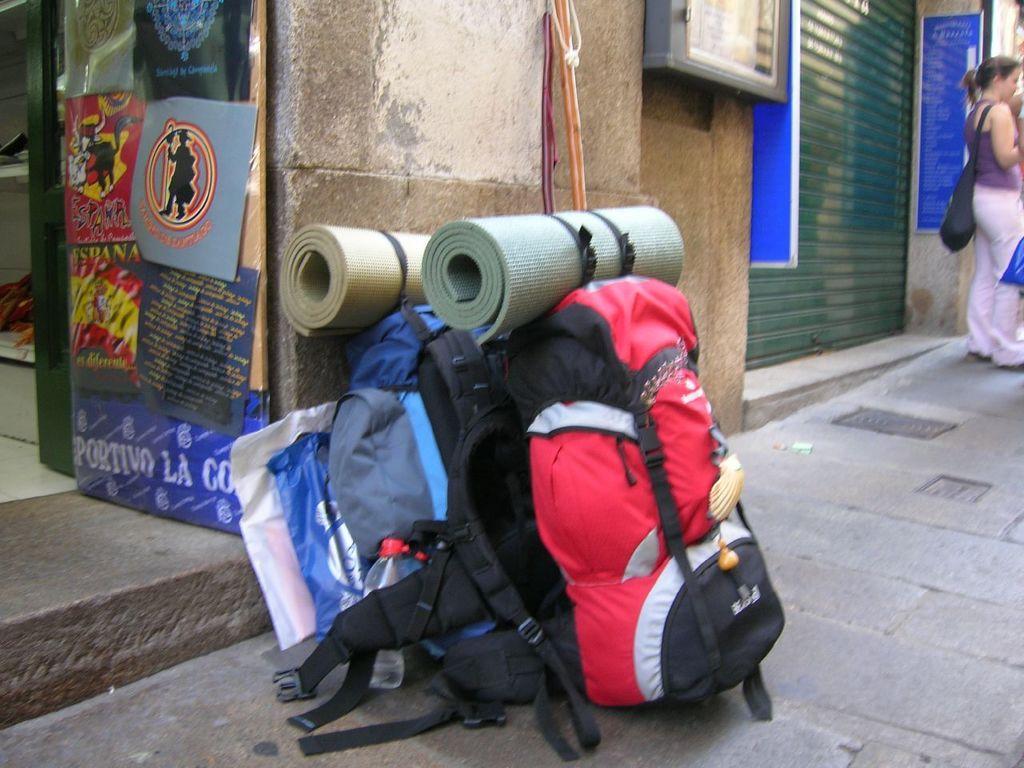Could you give a brief overview of what you see in this image? The image is taken outside of the city. In the image we can see a few luggage bags and a cover and two mat on it. On right side there is a woman who is wearing back pack and standing, we can also see blue color hoardings. On left side we can see a hoarding and a door which is opened 